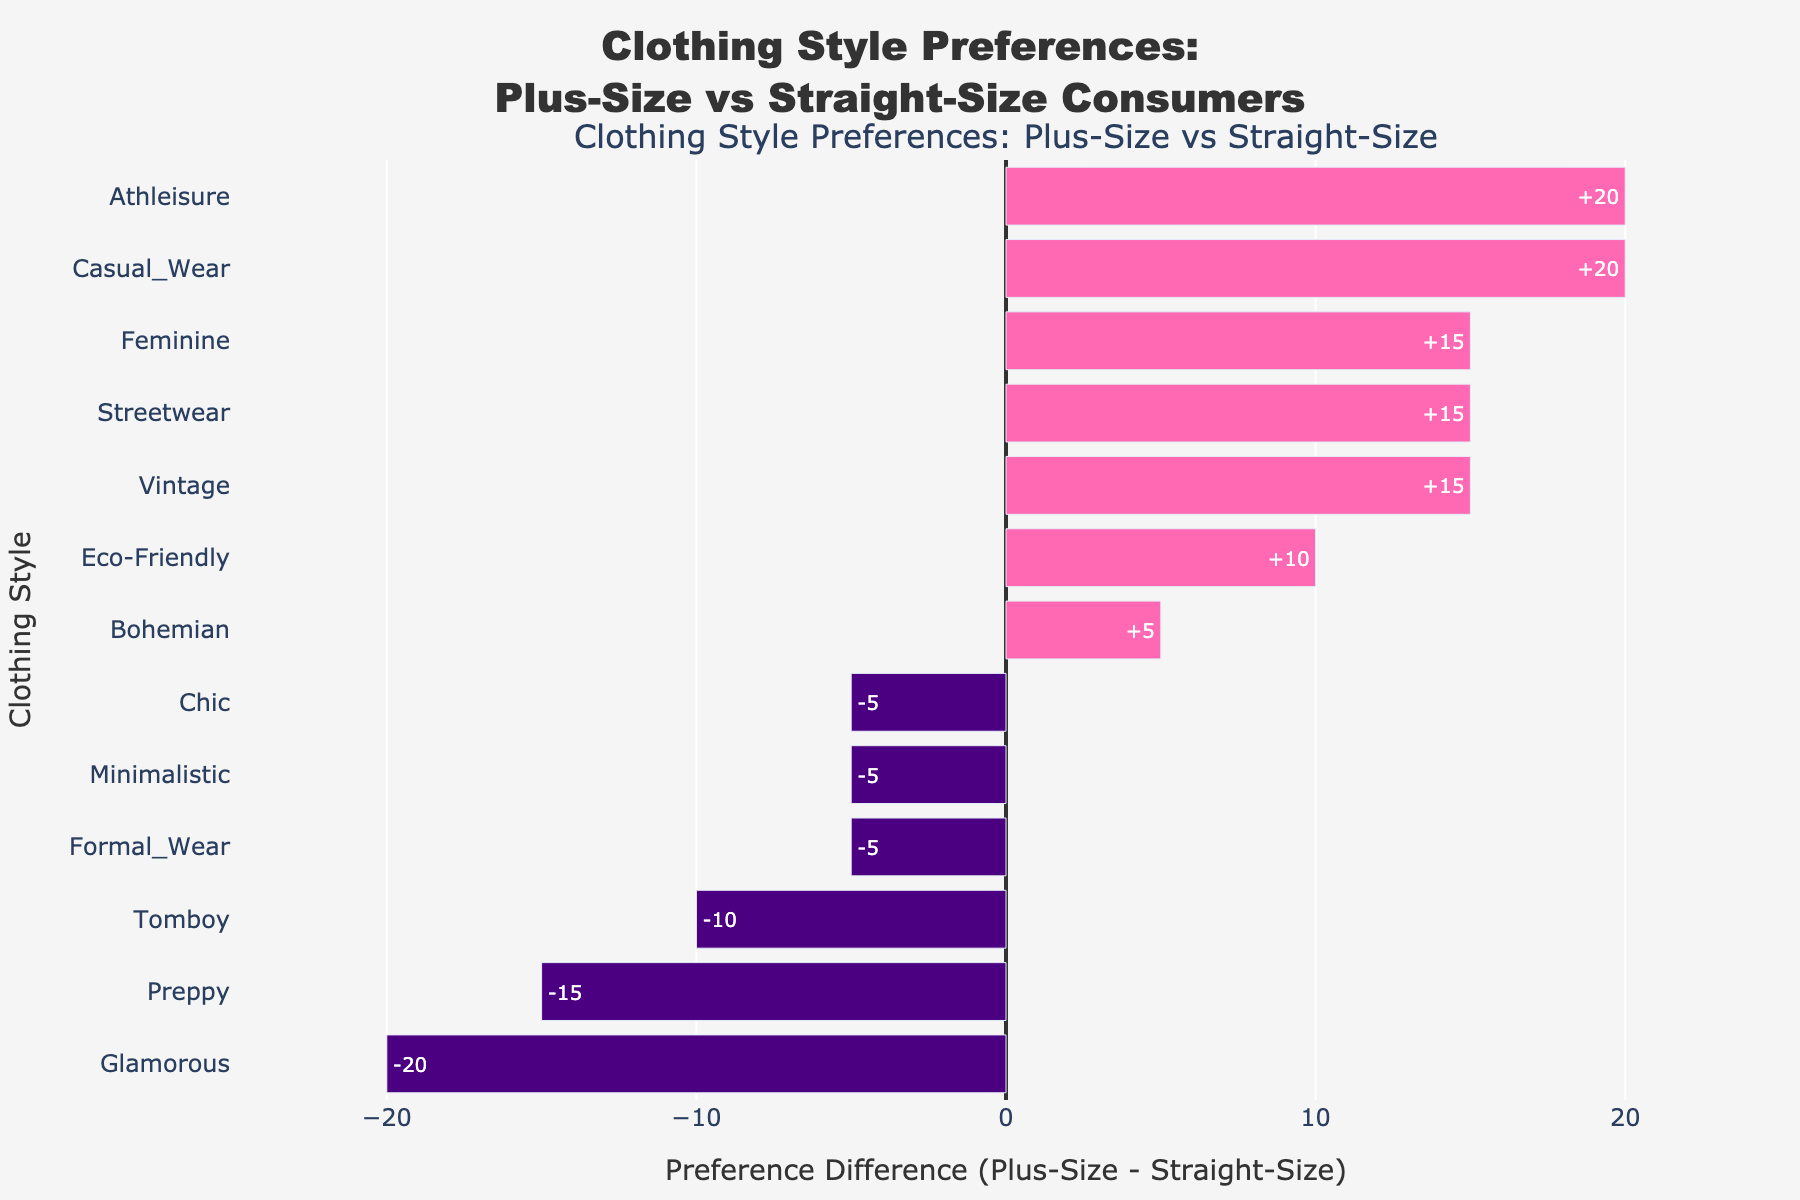Which clothing style shows the greatest preference difference in favor of plus-size consumers? The bar that extends farthest to the right represents the clothing style with the greatest preference difference in favor of plus-size consumers. This bar corresponds to the "Feminine" style.
Answer: Feminine Which style shows the greatest preference difference in favor of straight-size consumers? The bar that extends farthest to the left represents the clothing style with the greatest preference difference in favor of straight-size consumers. This bar corresponds to the "Glamorous" style.
Answer: Glamorous What is the combined preference difference for styles with positive differences? Sum the positive preference differences: Casual Wear (+20), Athleisure (+20), Bohemian (+5), Vintage (+15), Streetwear (+15), Feminine (+15), Eco-Friendly (+10). So, the combined preference difference is 20 + 20 + 5 + 15 + 15 + 15 + 10 = 100.
Answer: 100 Which styles are nearly equally preferred by both plus-size and straight-size consumers? Identify bars that are close to zero. "Bohemian" and "Eco-Friendly" have preferences differences of +5 and +10, suggesting near-equal preference levels.
Answer: Bohemian, Eco-Friendly How much higher is the preference for Chic style among straight-size consumers compared to plus-size consumers? The difference for Chic is -5. This means straight-size consumers have a 5% higher preference for Chic style than plus-size consumers.
Answer: 5% What are the three styles where straight-size consumers show higher preference than plus-size consumers? Identify the bars extending to the left. These include Formal Wear (-5), Minimalistic (-5), Glamorous (-20), and Preppy (-15). The three with the largest differences are therefore Glamorous, Preppy, and Minimalistic.
Answer: Glamorous, Preppy, Minimalistic Which clothing style has the smallest preference difference among all styles? The bar closest to zero represents the smallest preference difference. The "Bohemian" style has a difference of +5, which is the smallest absolute difference among all styles.
Answer: Bohemian Compare the preference difference between Athleisure and Minimalistic styles. Which one has a greater plus-size preference? Athleisure has a difference of +20 and Minimalistic has -5. Athleisure has a significantly greater preference among plus-size consumers than Minimalistic.
Answer: Athleisure For styles with a positive preference difference, what is the average preference difference? Sum the positive preference differences: Casual Wear (+20), Athleisure (+20), Bohemian (+5), Vintage (+15), Streetwear (+15), Feminine (+15), Eco-Friendly (+10). There are 7 such styles. The average is (20 + 20 + 5 + 15 + 15 + 15 + 10) / 7 = 100 / 7 ≈ 14.29.
Answer: 14.29 How does the preference for Streetwear among plus-size and straight-size consumers compare visually? The bar for Streetwear extends 15 units to the right, indicating plus-size consumers prefer Streetwear 15% more than straight-size consumers.
Answer: Plus-size prefer it 15% more 